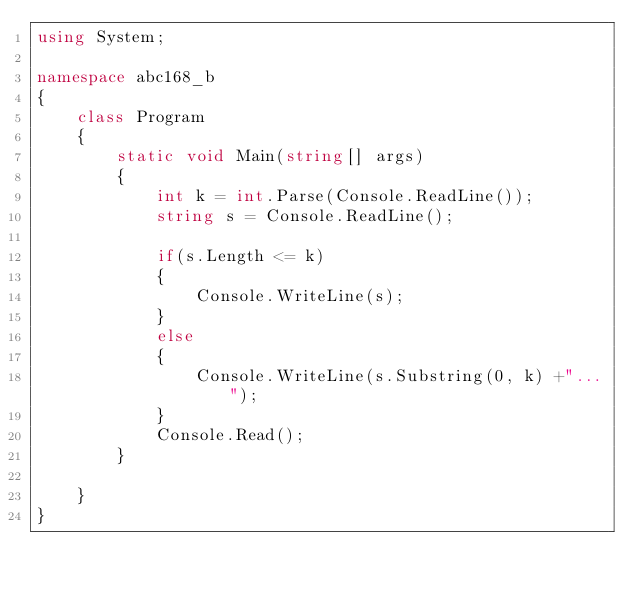<code> <loc_0><loc_0><loc_500><loc_500><_C#_>using System;

namespace abc168_b
{
    class Program
    {
        static void Main(string[] args)
        {
            int k = int.Parse(Console.ReadLine());
            string s = Console.ReadLine();

            if(s.Length <= k)
            {
                Console.WriteLine(s);
            }
            else
            {
                Console.WriteLine(s.Substring(0, k) +"...");
            }
            Console.Read();
        }
        
    }
}
</code> 